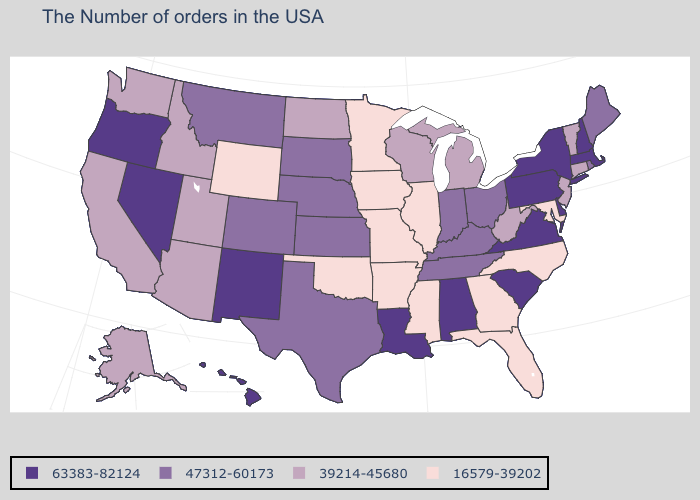Name the states that have a value in the range 63383-82124?
Give a very brief answer. Massachusetts, New Hampshire, New York, Delaware, Pennsylvania, Virginia, South Carolina, Alabama, Louisiana, New Mexico, Nevada, Oregon, Hawaii. Name the states that have a value in the range 16579-39202?
Give a very brief answer. Maryland, North Carolina, Florida, Georgia, Illinois, Mississippi, Missouri, Arkansas, Minnesota, Iowa, Oklahoma, Wyoming. What is the highest value in the West ?
Concise answer only. 63383-82124. What is the value of Alabama?
Write a very short answer. 63383-82124. Among the states that border Georgia , which have the lowest value?
Concise answer only. North Carolina, Florida. Does the map have missing data?
Short answer required. No. Does Nevada have the highest value in the USA?
Keep it brief. Yes. Does the map have missing data?
Short answer required. No. Which states have the lowest value in the USA?
Keep it brief. Maryland, North Carolina, Florida, Georgia, Illinois, Mississippi, Missouri, Arkansas, Minnesota, Iowa, Oklahoma, Wyoming. Name the states that have a value in the range 63383-82124?
Short answer required. Massachusetts, New Hampshire, New York, Delaware, Pennsylvania, Virginia, South Carolina, Alabama, Louisiana, New Mexico, Nevada, Oregon, Hawaii. What is the value of Nebraska?
Keep it brief. 47312-60173. Name the states that have a value in the range 16579-39202?
Concise answer only. Maryland, North Carolina, Florida, Georgia, Illinois, Mississippi, Missouri, Arkansas, Minnesota, Iowa, Oklahoma, Wyoming. Name the states that have a value in the range 39214-45680?
Quick response, please. Vermont, Connecticut, New Jersey, West Virginia, Michigan, Wisconsin, North Dakota, Utah, Arizona, Idaho, California, Washington, Alaska. Does California have a lower value than Wyoming?
Give a very brief answer. No. Among the states that border Nevada , does Idaho have the highest value?
Concise answer only. No. 